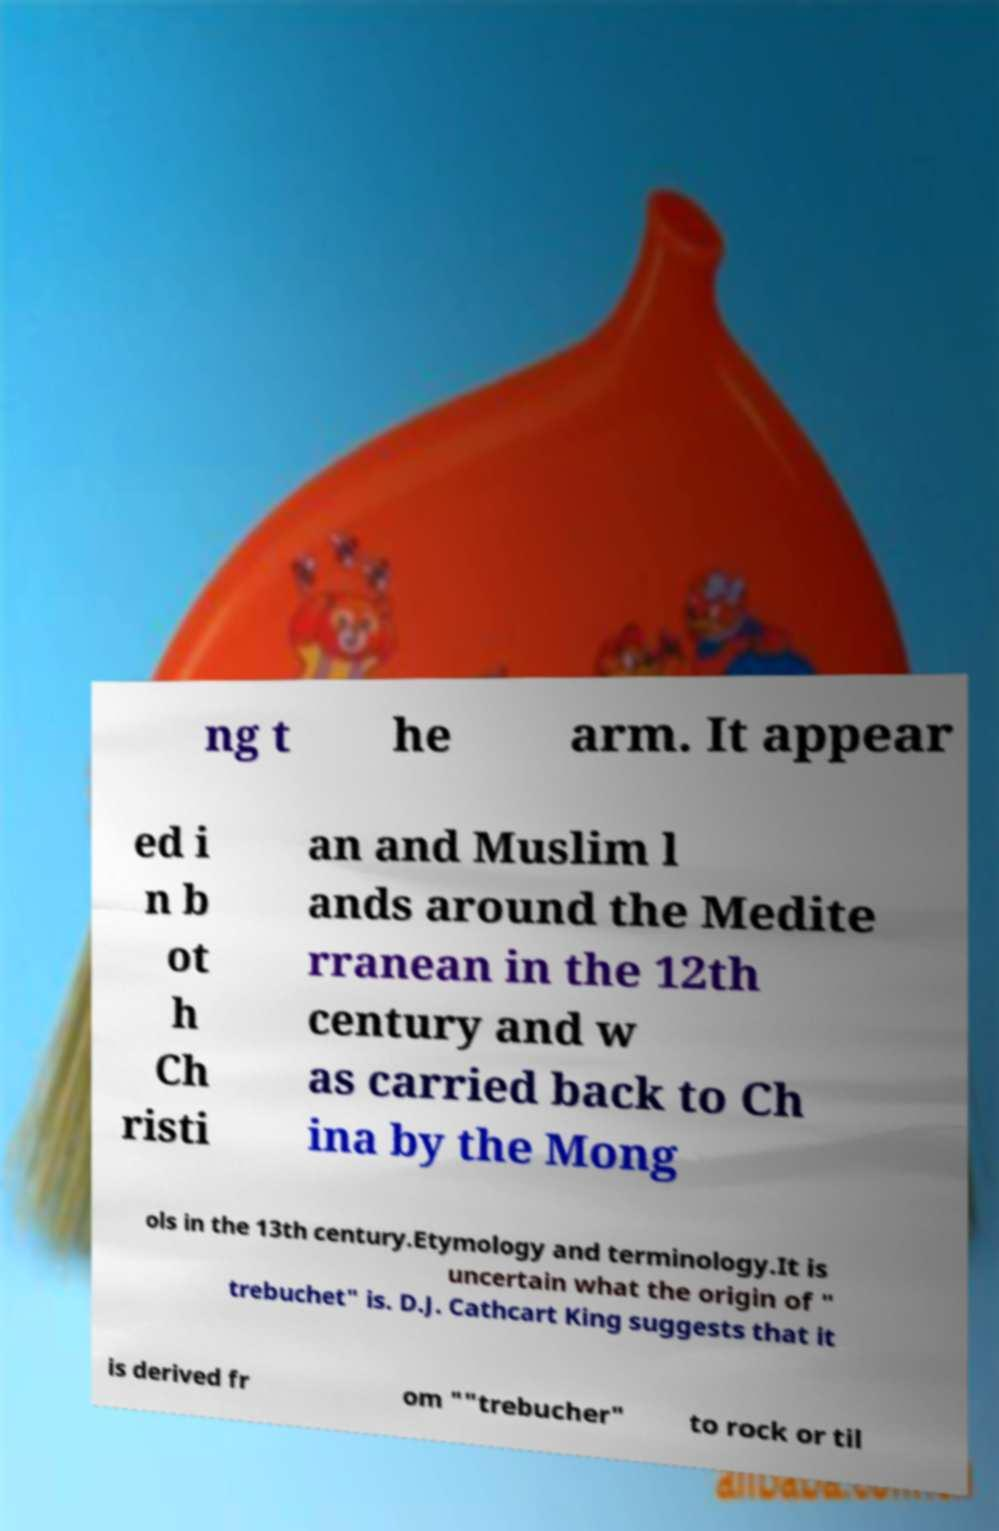Please read and relay the text visible in this image. What does it say? ng t he arm. It appear ed i n b ot h Ch risti an and Muslim l ands around the Medite rranean in the 12th century and w as carried back to Ch ina by the Mong ols in the 13th century.Etymology and terminology.It is uncertain what the origin of " trebuchet" is. D.J. Cathcart King suggests that it is derived fr om ""trebucher" to rock or til 